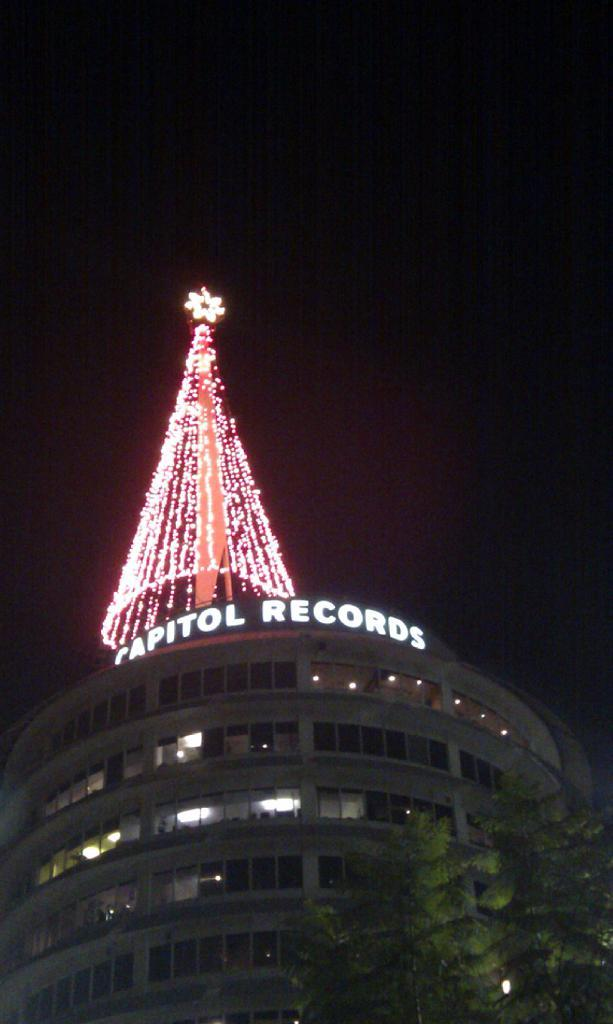What is the main structure in the image? There is a building in the image. What is above the building? There are lightings above the building. What type of vegetation is in front of the building? There is a tree in front of the building. How many pies are on the tree in the image? There are no pies present in the image; it features a building with lightings and a tree. 